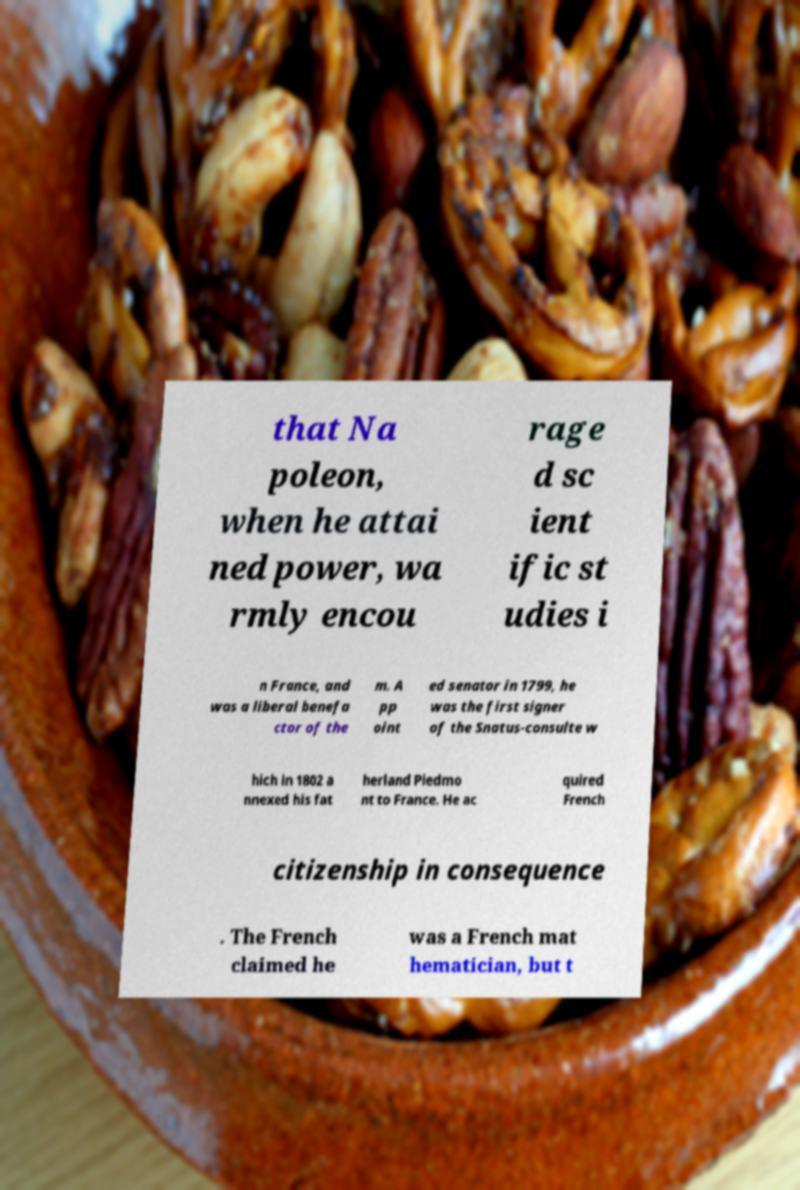Could you extract and type out the text from this image? that Na poleon, when he attai ned power, wa rmly encou rage d sc ient ific st udies i n France, and was a liberal benefa ctor of the m. A pp oint ed senator in 1799, he was the first signer of the Snatus-consulte w hich in 1802 a nnexed his fat herland Piedmo nt to France. He ac quired French citizenship in consequence . The French claimed he was a French mat hematician, but t 